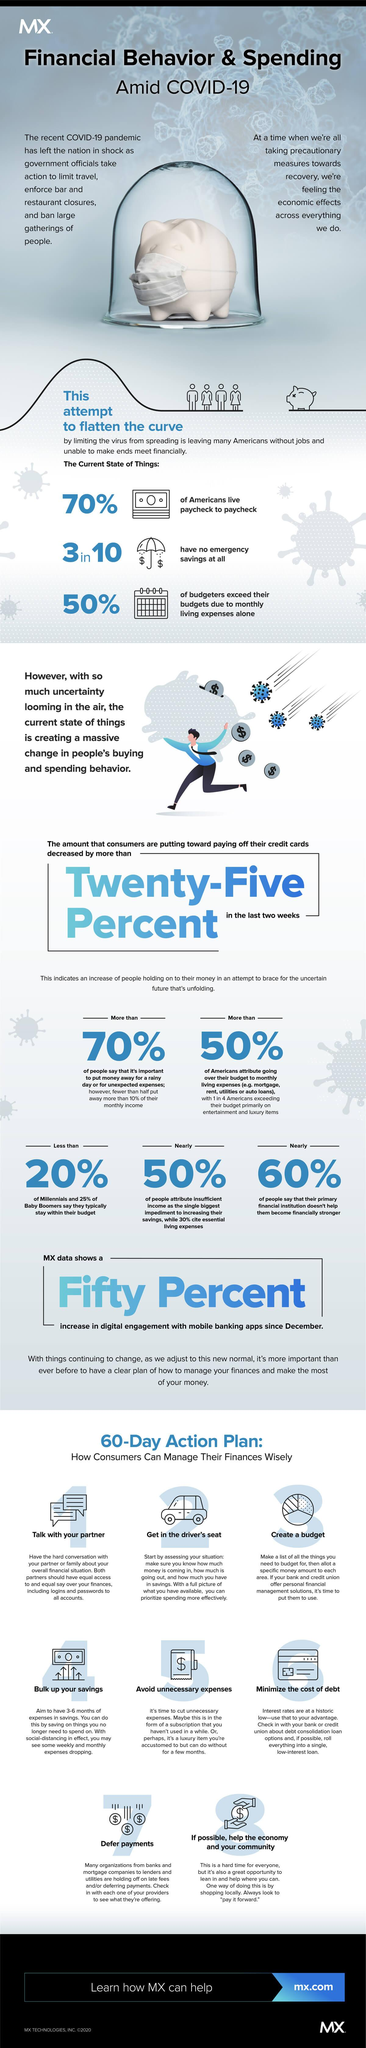Outline some significant characteristics in this image. According to a recent survey, 60% of Americans report that their primary financial institution has not assisted them in becoming financially stronger during the COVID-19 pandemic. According to a recent survey, only a small percentage of millennials, less than 20%, report that they typically stay within their budget amid the COVID-19 pandemic. 